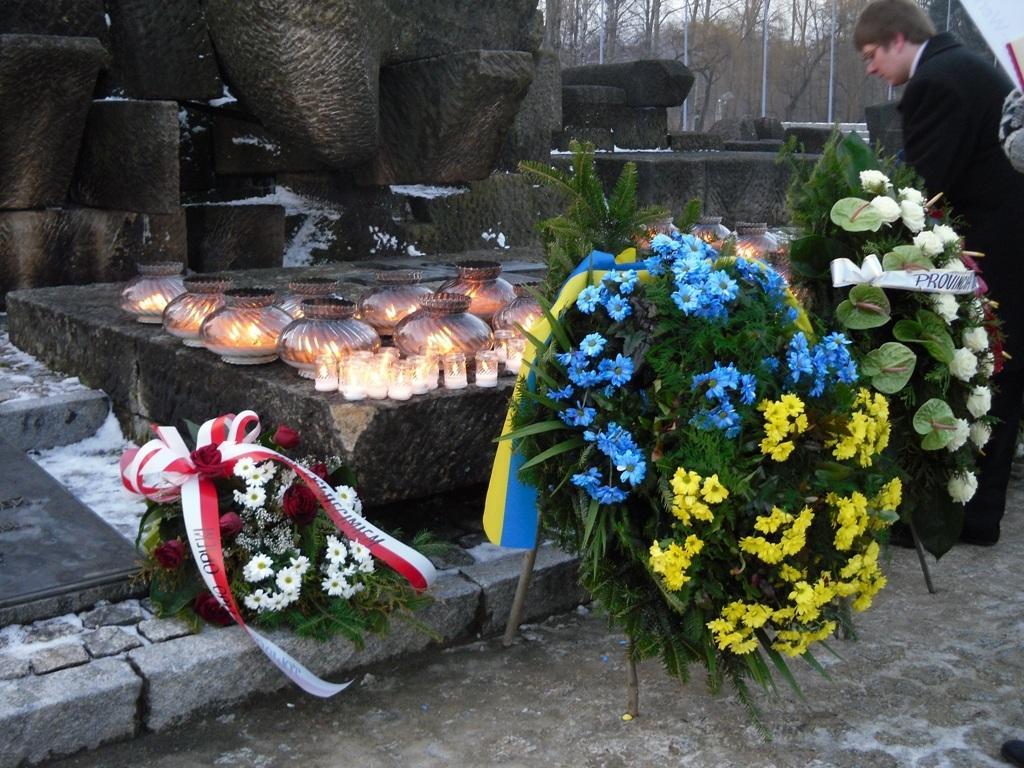Could you give a brief overview of what you see in this image? In this picture we can observe some bouquets placed on the floor. There are some candles and pots placed on this stone. In the right side there is a person standing. In the background there are some stones and trees here. 